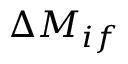Convert formula to latex. <formula><loc_0><loc_0><loc_500><loc_500>\Delta M _ { i f }</formula> 